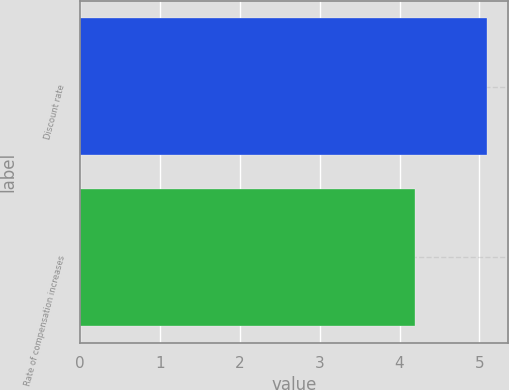Convert chart. <chart><loc_0><loc_0><loc_500><loc_500><bar_chart><fcel>Discount rate<fcel>Rate of compensation increases<nl><fcel>5.1<fcel>4.2<nl></chart> 